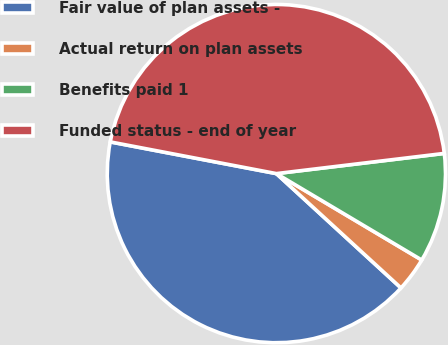<chart> <loc_0><loc_0><loc_500><loc_500><pie_chart><fcel>Fair value of plan assets -<fcel>Actual return on plan assets<fcel>Benefits paid 1<fcel>Funded status - end of year<nl><fcel>41.18%<fcel>3.28%<fcel>10.44%<fcel>45.09%<nl></chart> 